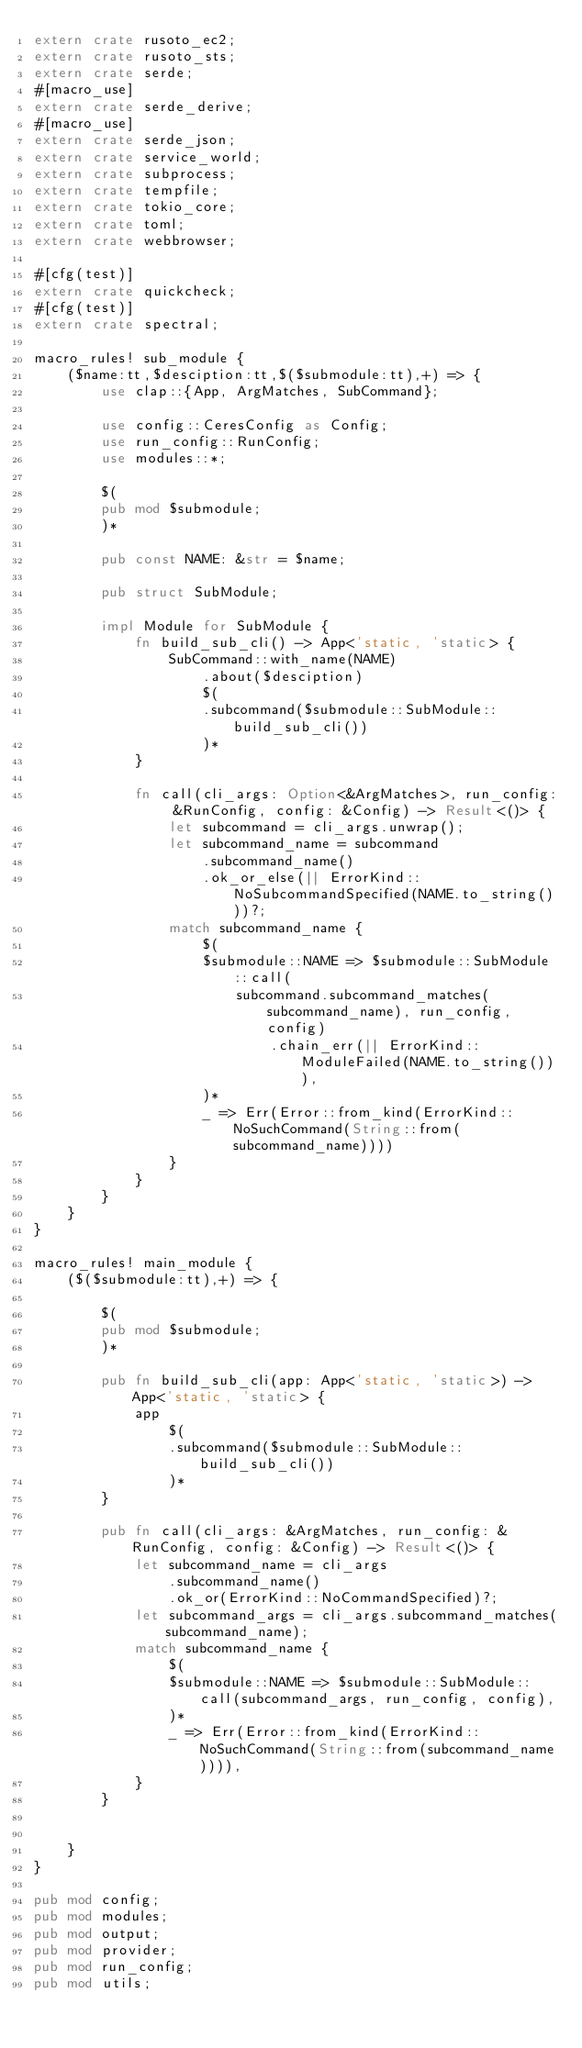<code> <loc_0><loc_0><loc_500><loc_500><_Rust_>extern crate rusoto_ec2;
extern crate rusoto_sts;
extern crate serde;
#[macro_use]
extern crate serde_derive;
#[macro_use]
extern crate serde_json;
extern crate service_world;
extern crate subprocess;
extern crate tempfile;
extern crate tokio_core;
extern crate toml;
extern crate webbrowser;

#[cfg(test)]
extern crate quickcheck;
#[cfg(test)]
extern crate spectral;

macro_rules! sub_module {
    ($name:tt,$desciption:tt,$($submodule:tt),+) => {
        use clap::{App, ArgMatches, SubCommand};

        use config::CeresConfig as Config;
        use run_config::RunConfig;
        use modules::*;

        $(
        pub mod $submodule;
        )*

        pub const NAME: &str = $name;

        pub struct SubModule;

        impl Module for SubModule {
            fn build_sub_cli() -> App<'static, 'static> {
                SubCommand::with_name(NAME)
                    .about($desciption)
                    $(
                    .subcommand($submodule::SubModule::build_sub_cli())
                    )*
            }

            fn call(cli_args: Option<&ArgMatches>, run_config: &RunConfig, config: &Config) -> Result<()> {
                let subcommand = cli_args.unwrap();
                let subcommand_name = subcommand
                    .subcommand_name()
                    .ok_or_else(|| ErrorKind::NoSubcommandSpecified(NAME.to_string()))?;
                match subcommand_name {
                    $(
                    $submodule::NAME => $submodule::SubModule::call(
                        subcommand.subcommand_matches(subcommand_name), run_config, config)
                            .chain_err(|| ErrorKind::ModuleFailed(NAME.to_string())),
                    )*
                    _ => Err(Error::from_kind(ErrorKind::NoSuchCommand(String::from(subcommand_name))))
                }
            }
        }
    }
}

macro_rules! main_module {
    ($($submodule:tt),+) => {

        $(
        pub mod $submodule;
        )*

        pub fn build_sub_cli(app: App<'static, 'static>) -> App<'static, 'static> {
            app
                $(
                .subcommand($submodule::SubModule::build_sub_cli())
                )*
        }

        pub fn call(cli_args: &ArgMatches, run_config: &RunConfig, config: &Config) -> Result<()> {
            let subcommand_name = cli_args
                .subcommand_name()
                .ok_or(ErrorKind::NoCommandSpecified)?;
            let subcommand_args = cli_args.subcommand_matches(subcommand_name);
            match subcommand_name {
                $(
                $submodule::NAME => $submodule::SubModule::call(subcommand_args, run_config, config),
                )*
                _ => Err(Error::from_kind(ErrorKind::NoSuchCommand(String::from(subcommand_name)))),
            }
        }


    }
}

pub mod config;
pub mod modules;
pub mod output;
pub mod provider;
pub mod run_config;
pub mod utils;
</code> 